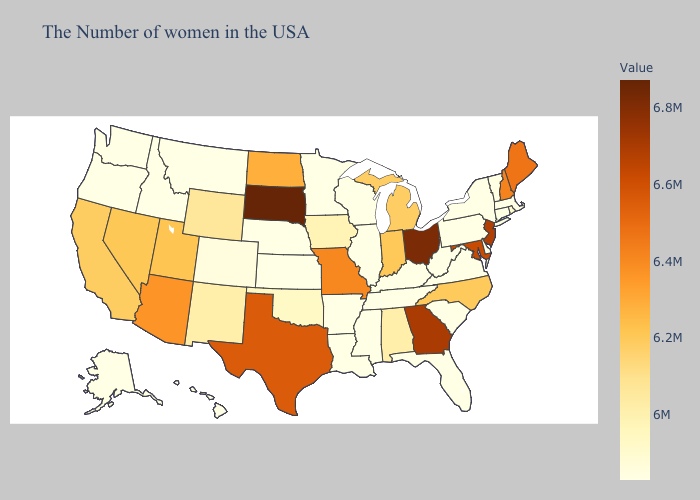Among the states that border Colorado , which have the highest value?
Be succinct. Arizona. Does South Dakota have the highest value in the USA?
Keep it brief. Yes. Does the map have missing data?
Keep it brief. No. Does Iowa have a higher value than Florida?
Quick response, please. Yes. Among the states that border Oregon , does Washington have the highest value?
Concise answer only. No. Among the states that border Tennessee , does Georgia have the highest value?
Write a very short answer. Yes. 